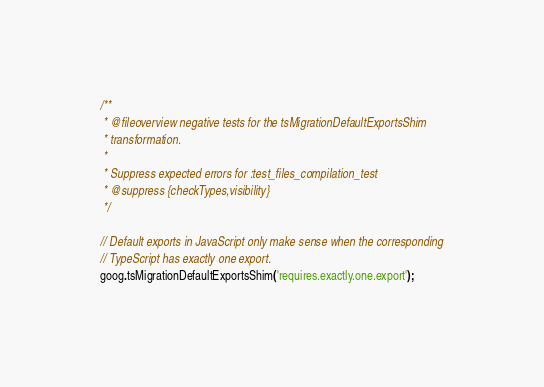Convert code to text. <code><loc_0><loc_0><loc_500><loc_500><_TypeScript_>/**
 * @fileoverview negative tests for the tsMigrationDefaultExportsShim
 * transformation.
 *
 * Suppress expected errors for :test_files_compilation_test
 * @suppress {checkTypes,visibility}
 */

// Default exports in JavaScript only make sense when the corresponding
// TypeScript has exactly one export.
goog.tsMigrationDefaultExportsShim('requires.exactly.one.export');
</code> 